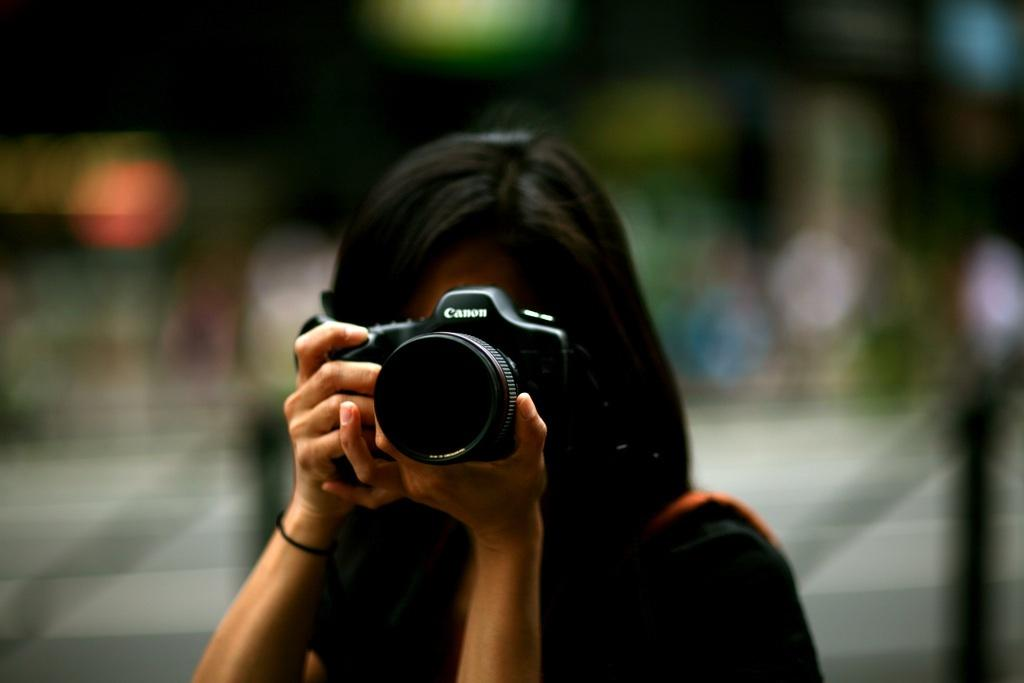Who is the main subject in the picture? There is a woman in the picture. Where is the woman positioned in the image? The woman is standing in the middle of the image. What is the woman holding in the image? The woman is holding a camera. What can be said about the color of the camera? The camera is black in color. What is the woman doing with the camera? The woman is taking a picture. How many lizards can be seen crawling on the camera in the image? There are no lizards present in the image, and therefore no such activity can be observed. 